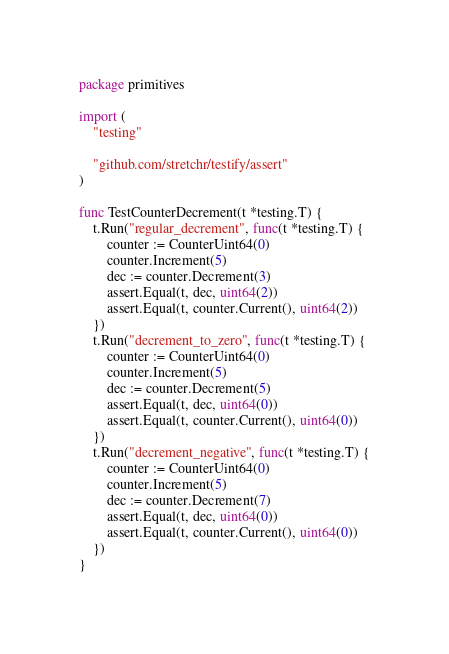<code> <loc_0><loc_0><loc_500><loc_500><_Go_>package primitives

import (
	"testing"

	"github.com/stretchr/testify/assert"
)

func TestCounterDecrement(t *testing.T) {
	t.Run("regular_decrement", func(t *testing.T) {
		counter := CounterUint64(0)
		counter.Increment(5)
		dec := counter.Decrement(3)
		assert.Equal(t, dec, uint64(2))
		assert.Equal(t, counter.Current(), uint64(2))
	})
	t.Run("decrement_to_zero", func(t *testing.T) {
		counter := CounterUint64(0)
		counter.Increment(5)
		dec := counter.Decrement(5)
		assert.Equal(t, dec, uint64(0))
		assert.Equal(t, counter.Current(), uint64(0))
	})
	t.Run("decrement_negative", func(t *testing.T) {
		counter := CounterUint64(0)
		counter.Increment(5)
		dec := counter.Decrement(7)
		assert.Equal(t, dec, uint64(0))
		assert.Equal(t, counter.Current(), uint64(0))
	})
}
</code> 